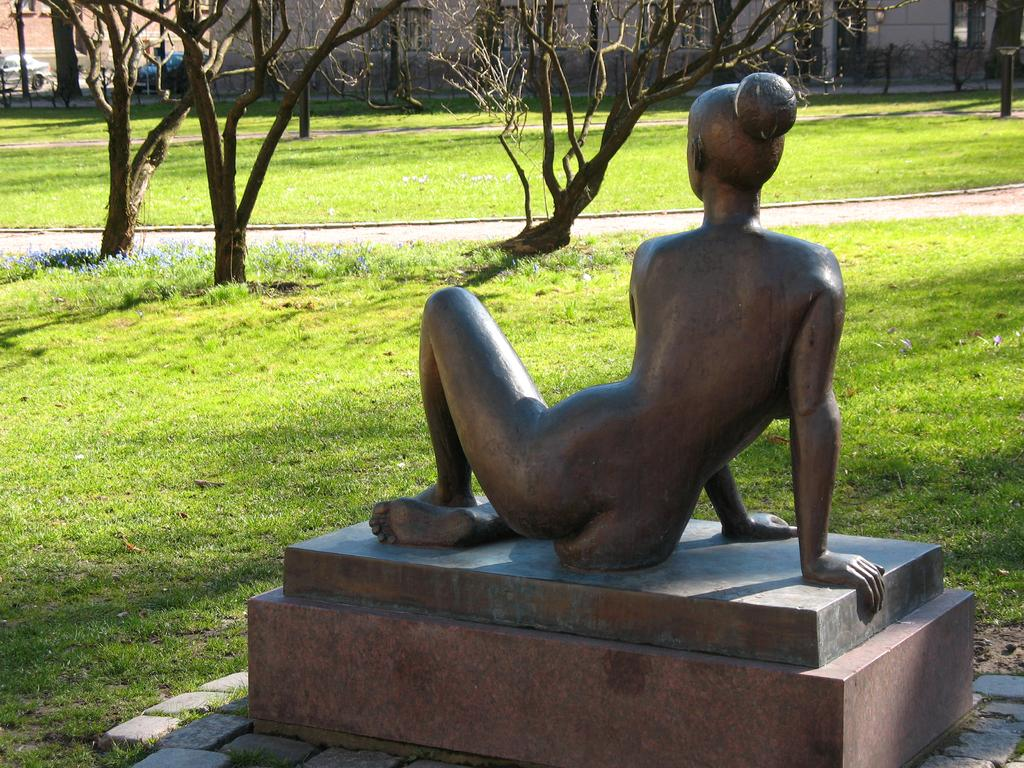What is the main subject of the image? There is a statue of a person in the image. What type of surface is the statue standing on? There is grass on the ground in the image. What other natural elements can be seen in the image? There are trees visible in the image. What type of grain is being harvested in the image? There is no grain or harvesting activity present in the image; it features a statue and natural elements like grass and trees. 